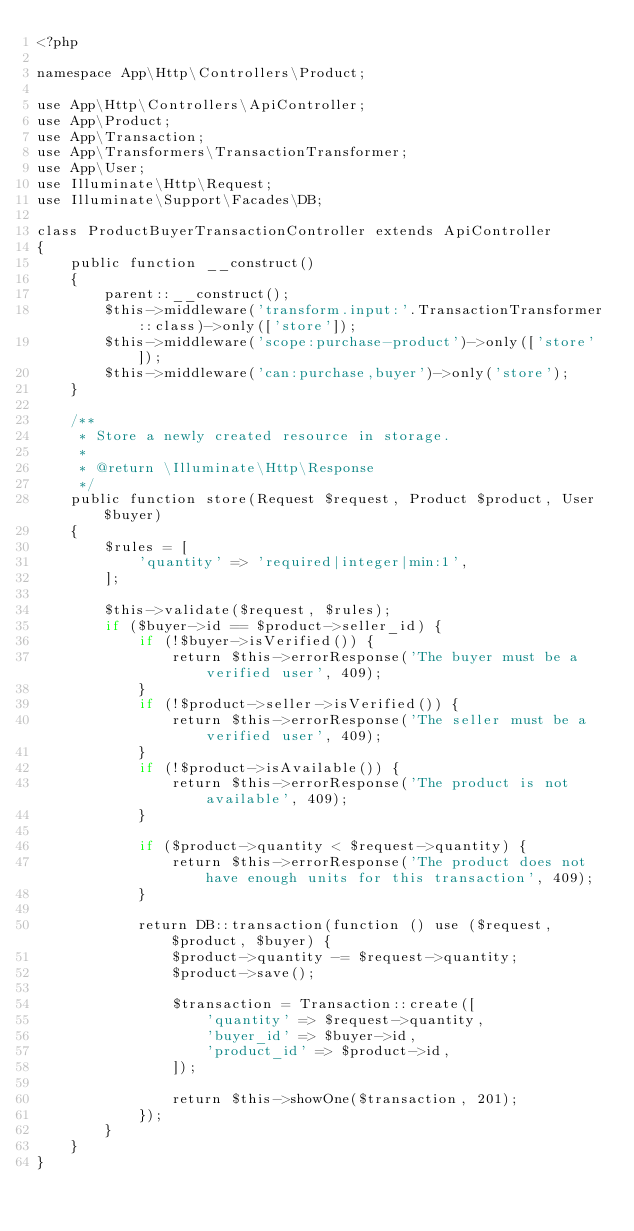<code> <loc_0><loc_0><loc_500><loc_500><_PHP_><?php

namespace App\Http\Controllers\Product;

use App\Http\Controllers\ApiController;
use App\Product;
use App\Transaction;
use App\Transformers\TransactionTransformer;
use App\User;
use Illuminate\Http\Request;
use Illuminate\Support\Facades\DB;

class ProductBuyerTransactionController extends ApiController
{
    public function __construct()
    {
        parent::__construct();
        $this->middleware('transform.input:'.TransactionTransformer::class)->only(['store']);
        $this->middleware('scope:purchase-product')->only(['store']);
        $this->middleware('can:purchase,buyer')->only('store');
    }

    /**
     * Store a newly created resource in storage.
     *
     * @return \Illuminate\Http\Response
     */
    public function store(Request $request, Product $product, User $buyer)
    {
        $rules = [
            'quantity' => 'required|integer|min:1',
        ];

        $this->validate($request, $rules);
        if ($buyer->id == $product->seller_id) {
            if (!$buyer->isVerified()) {
                return $this->errorResponse('The buyer must be a verified user', 409);
            }
            if (!$product->seller->isVerified()) {
                return $this->errorResponse('The seller must be a verified user', 409);
            }
            if (!$product->isAvailable()) {
                return $this->errorResponse('The product is not available', 409);
            }

            if ($product->quantity < $request->quantity) {
                return $this->errorResponse('The product does not have enough units for this transaction', 409);
            }

            return DB::transaction(function () use ($request, $product, $buyer) {
                $product->quantity -= $request->quantity;
                $product->save();

                $transaction = Transaction::create([
                    'quantity' => $request->quantity,
                    'buyer_id' => $buyer->id,
                    'product_id' => $product->id,
                ]);

                return $this->showOne($transaction, 201);
            });
        }
    }
}
</code> 